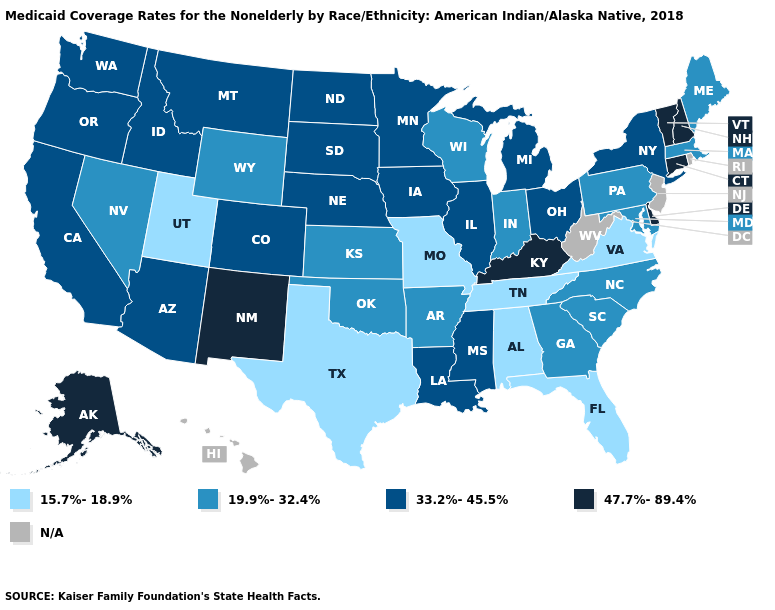Which states have the lowest value in the Northeast?
Be succinct. Maine, Massachusetts, Pennsylvania. Name the states that have a value in the range 15.7%-18.9%?
Keep it brief. Alabama, Florida, Missouri, Tennessee, Texas, Utah, Virginia. Does South Dakota have the highest value in the MidWest?
Be succinct. Yes. Does Nebraska have the highest value in the MidWest?
Give a very brief answer. Yes. Which states have the lowest value in the MidWest?
Short answer required. Missouri. What is the lowest value in the West?
Give a very brief answer. 15.7%-18.9%. What is the value of North Carolina?
Keep it brief. 19.9%-32.4%. How many symbols are there in the legend?
Quick response, please. 5. What is the value of North Dakota?
Be succinct. 33.2%-45.5%. Does Massachusetts have the lowest value in the Northeast?
Give a very brief answer. Yes. Does Vermont have the highest value in the Northeast?
Write a very short answer. Yes. Name the states that have a value in the range N/A?
Keep it brief. Hawaii, New Jersey, Rhode Island, West Virginia. Does Connecticut have the highest value in the USA?
Quick response, please. Yes. What is the value of Vermont?
Be succinct. 47.7%-89.4%. What is the value of Washington?
Short answer required. 33.2%-45.5%. 